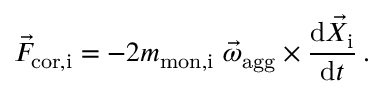Convert formula to latex. <formula><loc_0><loc_0><loc_500><loc_500>\vec { F } _ { c o r , i } = - 2 m _ { m o n , i } \ \vec { \omega } _ { a g g } \times \frac { d \vec { X } _ { i } } { d t } \, .</formula> 